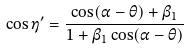Convert formula to latex. <formula><loc_0><loc_0><loc_500><loc_500>\cos \eta ^ { \prime } = \frac { \cos ( \alpha - \theta ) + \beta _ { 1 } } { 1 + \beta _ { 1 } \cos ( \alpha - \theta ) }</formula> 